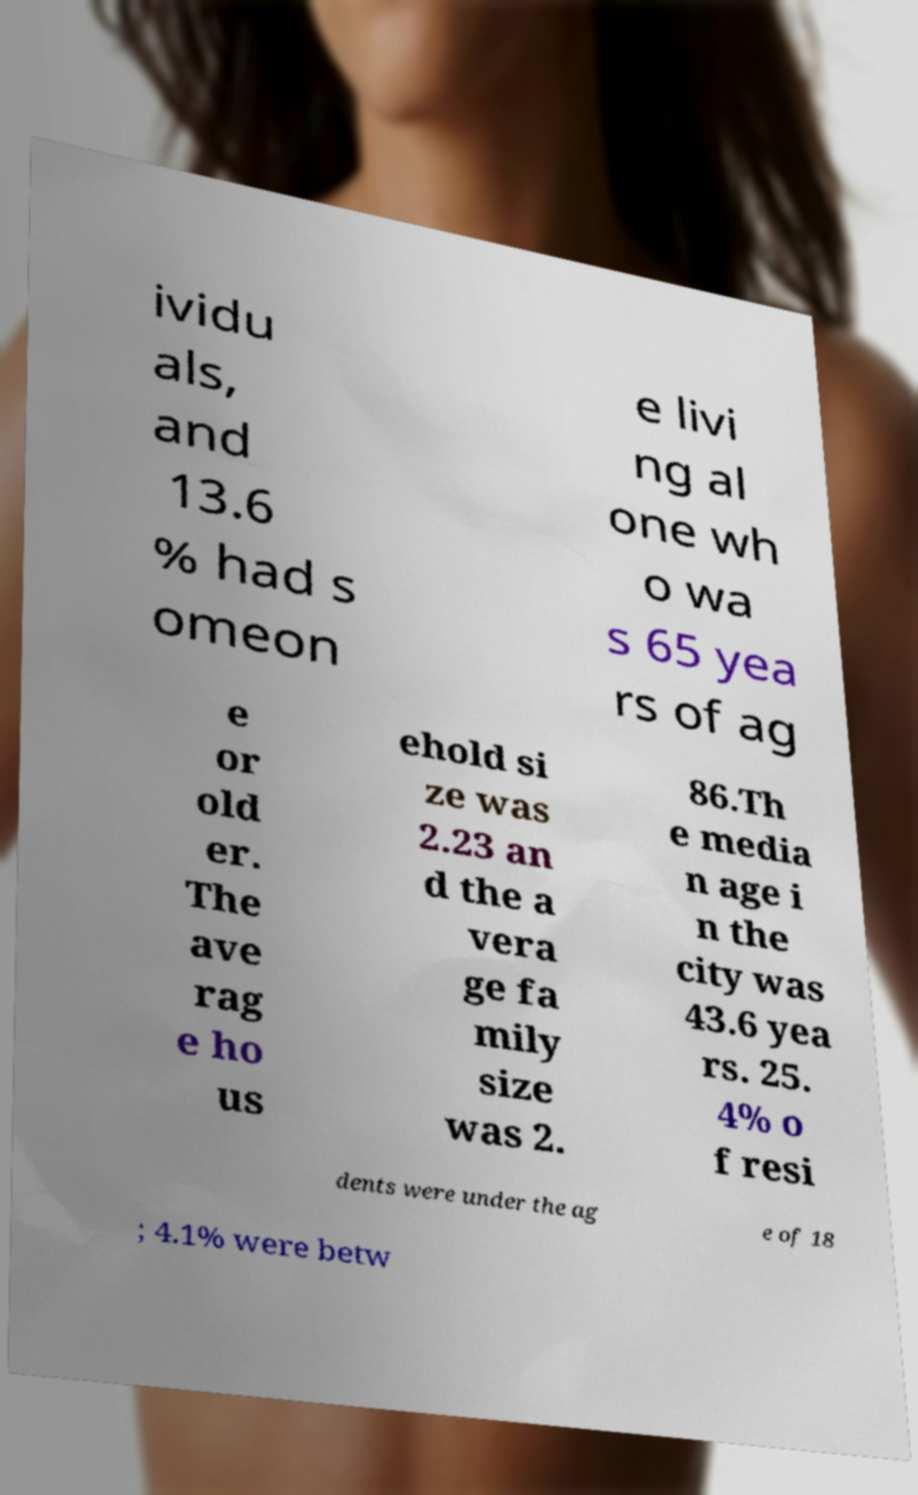Please identify and transcribe the text found in this image. ividu als, and 13.6 % had s omeon e livi ng al one wh o wa s 65 yea rs of ag e or old er. The ave rag e ho us ehold si ze was 2.23 an d the a vera ge fa mily size was 2. 86.Th e media n age i n the city was 43.6 yea rs. 25. 4% o f resi dents were under the ag e of 18 ; 4.1% were betw 